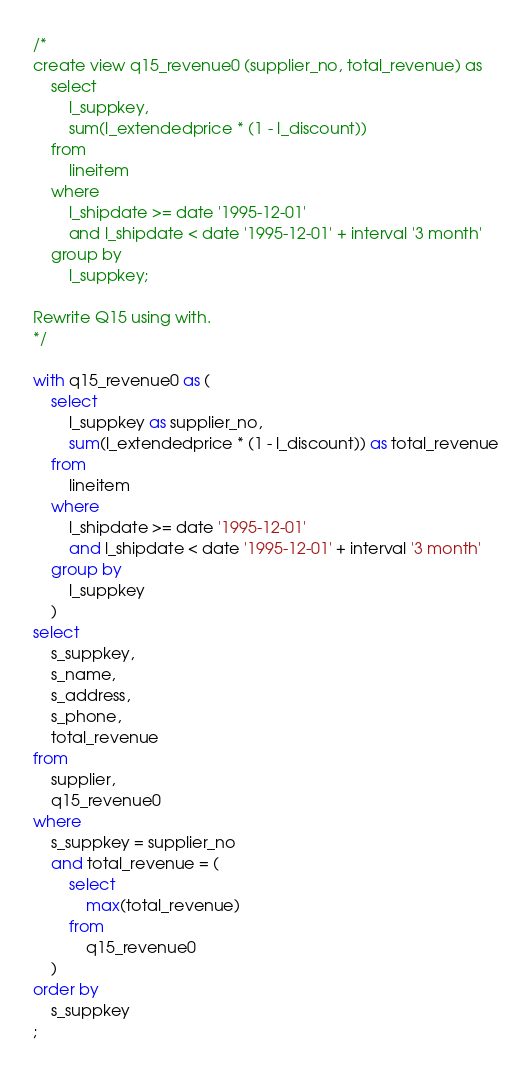Convert code to text. <code><loc_0><loc_0><loc_500><loc_500><_SQL_>/*
create view q15_revenue0 (supplier_no, total_revenue) as
	select
		l_suppkey,
		sum(l_extendedprice * (1 - l_discount))
	from
		lineitem
	where
		l_shipdate >= date '1995-12-01'
		and l_shipdate < date '1995-12-01' + interval '3 month'
	group by
		l_suppkey;

Rewrite Q15 using with.
*/

with q15_revenue0 as (
	select
		l_suppkey as supplier_no,
		sum(l_extendedprice * (1 - l_discount)) as total_revenue
	from
		lineitem
	where
		l_shipdate >= date '1995-12-01'
		and l_shipdate < date '1995-12-01' + interval '3 month'
	group by
		l_suppkey
    )
select
	s_suppkey,
	s_name,
	s_address,
	s_phone,
	total_revenue
from
	supplier,
	q15_revenue0
where
	s_suppkey = supplier_no
	and total_revenue = (
		select
			max(total_revenue)
		from
			q15_revenue0
	)
order by
	s_suppkey
;
</code> 